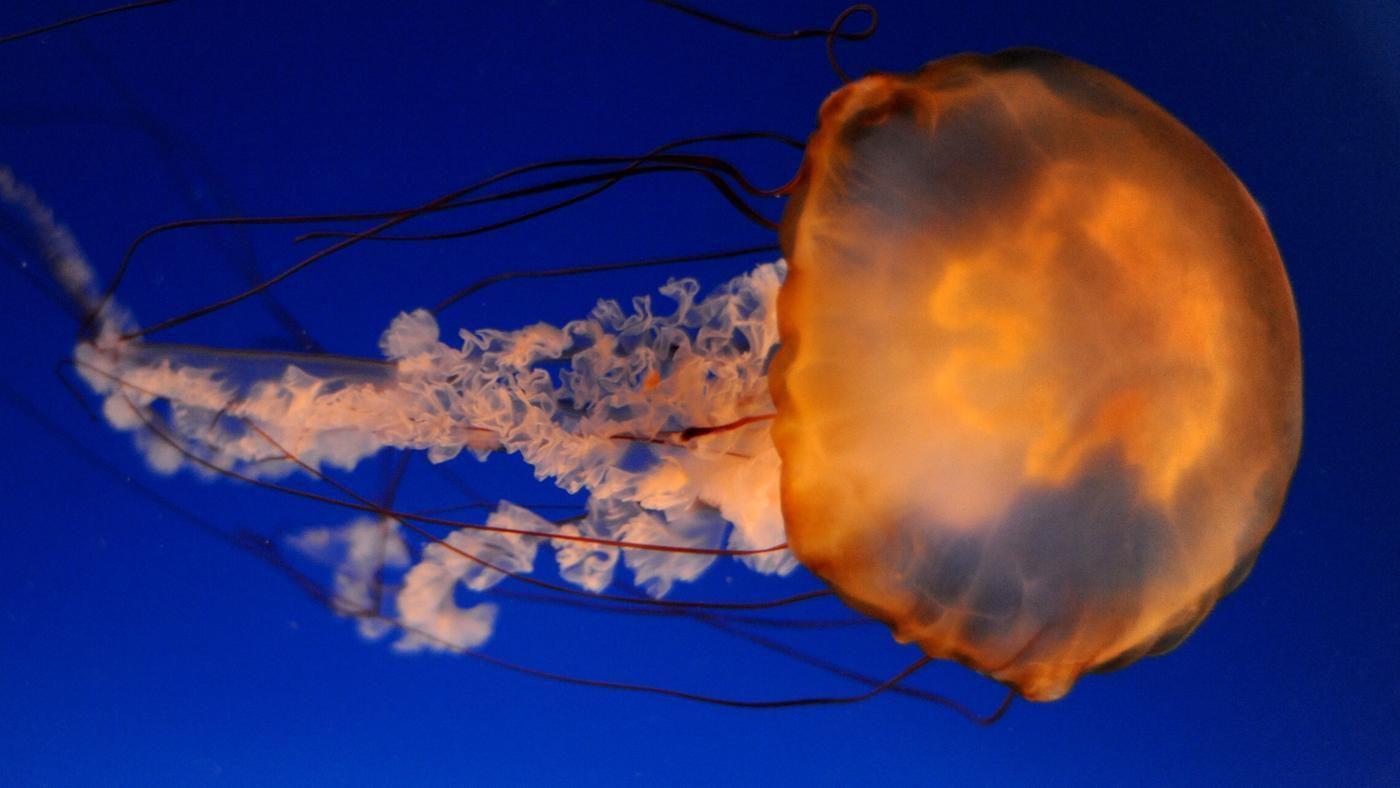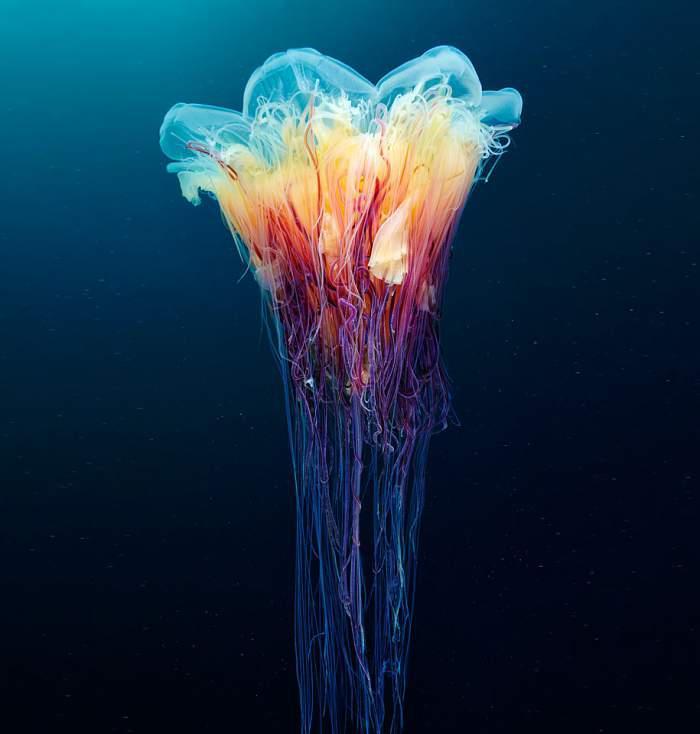The first image is the image on the left, the second image is the image on the right. Analyze the images presented: Is the assertion "At least one jellyfish has a polka dot body." valid? Answer yes or no. No. The first image is the image on the left, the second image is the image on the right. For the images displayed, is the sentence "The left image features one orange-capped jellyfish moving horizontally with threadlike and ruffled-look tentacles trailing behind it." factually correct? Answer yes or no. Yes. 